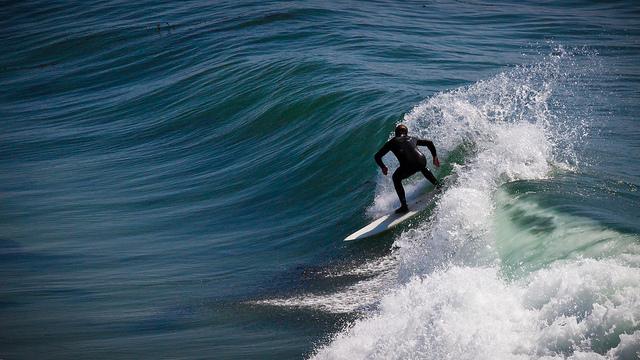Does the surfer look like Spiderman?
Write a very short answer. Yes. Is there a shark in the water?
Keep it brief. No. Is this surfer falling into the wave?
Answer briefly. No. Is there a wave?
Short answer required. Yes. 